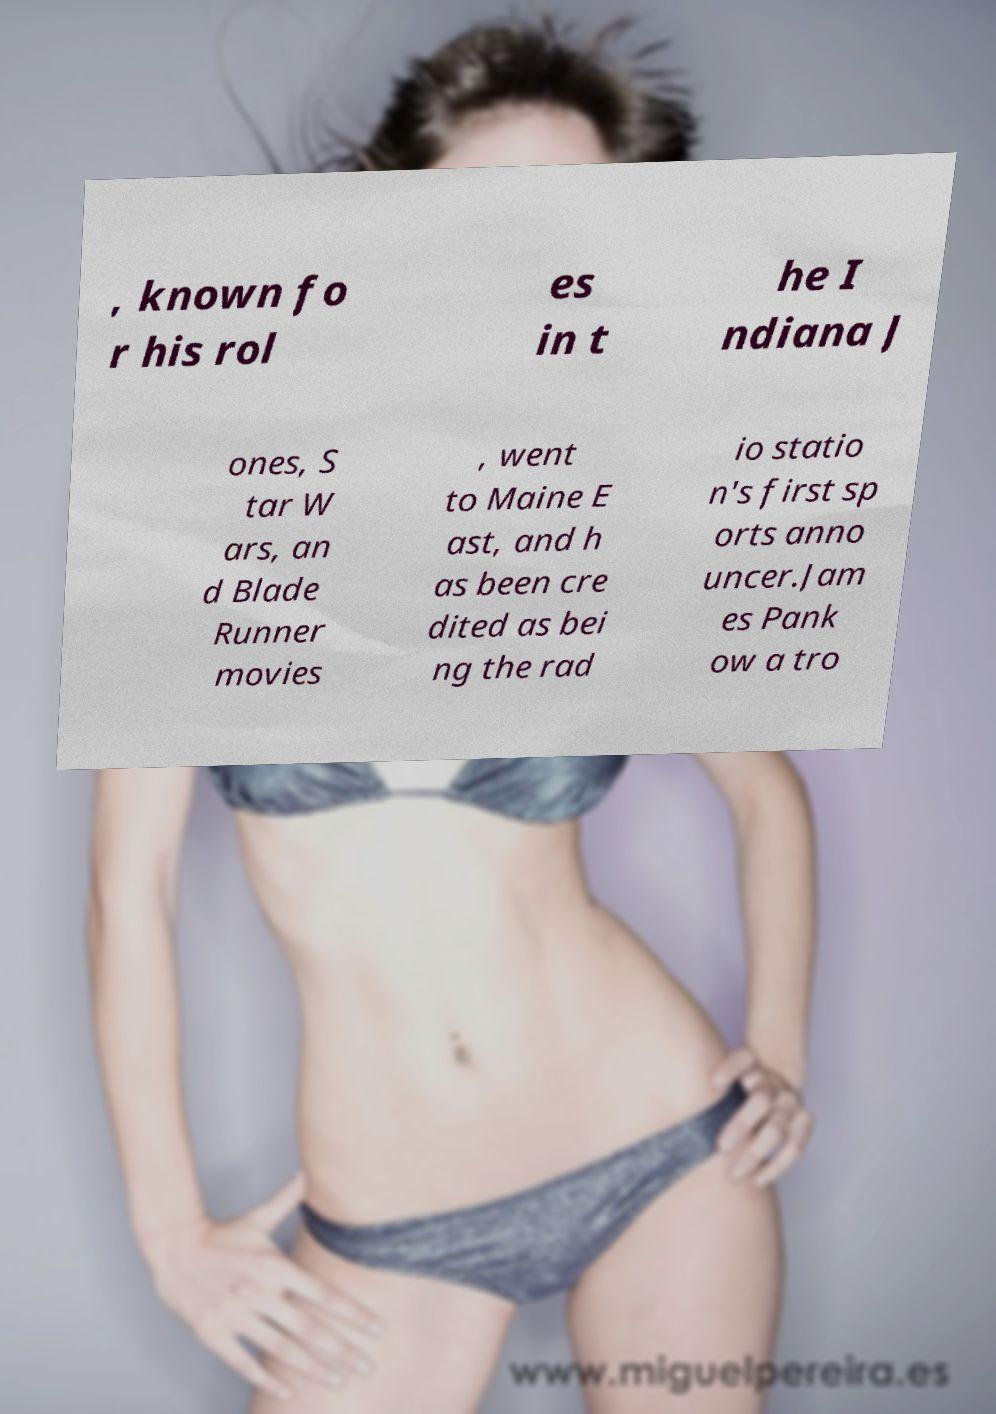Can you accurately transcribe the text from the provided image for me? , known fo r his rol es in t he I ndiana J ones, S tar W ars, an d Blade Runner movies , went to Maine E ast, and h as been cre dited as bei ng the rad io statio n's first sp orts anno uncer.Jam es Pank ow a tro 